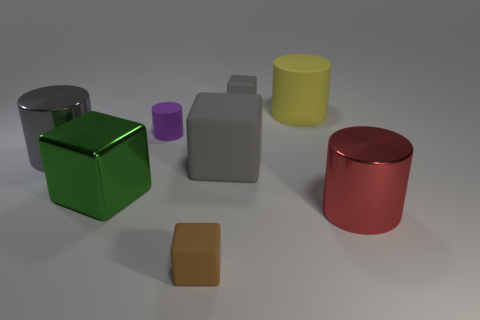Subtract all small gray blocks. How many blocks are left? 3 Add 1 small rubber cylinders. How many objects exist? 9 Subtract all yellow spheres. How many gray blocks are left? 2 Subtract all gray blocks. How many blocks are left? 2 Subtract 0 purple balls. How many objects are left? 8 Subtract all purple blocks. Subtract all brown cylinders. How many blocks are left? 4 Subtract all large blue rubber balls. Subtract all green shiny cubes. How many objects are left? 7 Add 8 big gray metallic things. How many big gray metallic things are left? 9 Add 2 big gray objects. How many big gray objects exist? 4 